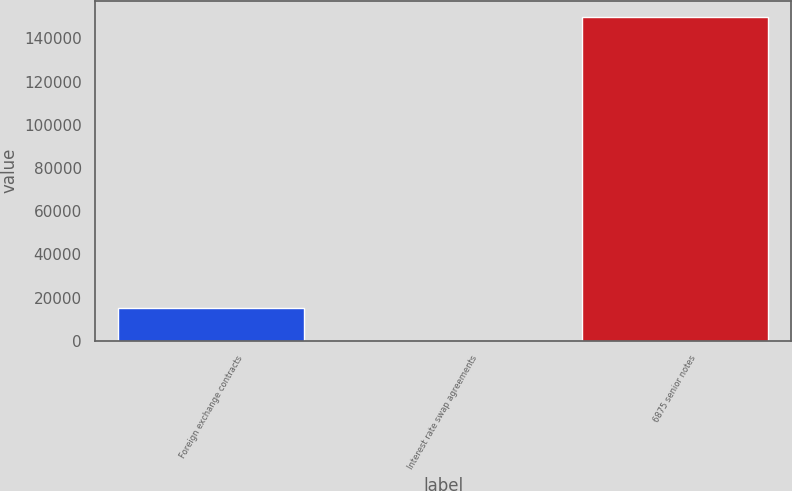<chart> <loc_0><loc_0><loc_500><loc_500><bar_chart><fcel>Foreign exchange contracts<fcel>Interest rate swap agreements<fcel>6875 senior notes<nl><fcel>15056.7<fcel>63<fcel>150000<nl></chart> 